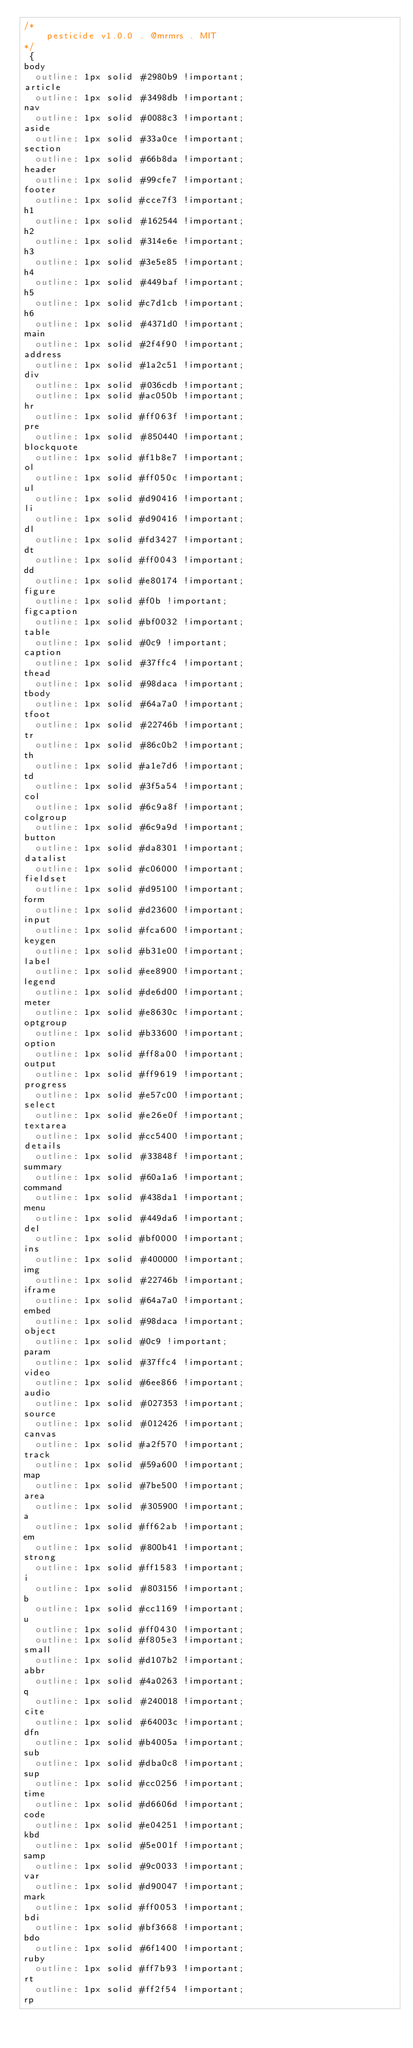Convert code to text. <code><loc_0><loc_0><loc_500><loc_500><_CSS_>/*
    pesticide v1.0.0 . @mrmrs . MIT
*/
 {
body
  outline: 1px solid #2980b9 !important;
article
  outline: 1px solid #3498db !important;
nav
  outline: 1px solid #0088c3 !important;
aside
  outline: 1px solid #33a0ce !important;
section
  outline: 1px solid #66b8da !important;
header
  outline: 1px solid #99cfe7 !important;
footer
  outline: 1px solid #cce7f3 !important;
h1
  outline: 1px solid #162544 !important;
h2
  outline: 1px solid #314e6e !important;
h3
  outline: 1px solid #3e5e85 !important;
h4
  outline: 1px solid #449baf !important;
h5
  outline: 1px solid #c7d1cb !important;
h6
  outline: 1px solid #4371d0 !important;
main
  outline: 1px solid #2f4f90 !important;
address
  outline: 1px solid #1a2c51 !important;
div
  outline: 1px solid #036cdb !important;
  outline: 1px solid #ac050b !important;
hr
  outline: 1px solid #ff063f !important;
pre
  outline: 1px solid #850440 !important;
blockquote
  outline: 1px solid #f1b8e7 !important;
ol
  outline: 1px solid #ff050c !important;
ul
  outline: 1px solid #d90416 !important;
li
  outline: 1px solid #d90416 !important;
dl
  outline: 1px solid #fd3427 !important;
dt
  outline: 1px solid #ff0043 !important;
dd
  outline: 1px solid #e80174 !important;
figure
  outline: 1px solid #f0b !important;
figcaption
  outline: 1px solid #bf0032 !important;
table
  outline: 1px solid #0c9 !important;
caption
  outline: 1px solid #37ffc4 !important;
thead
  outline: 1px solid #98daca !important;
tbody
  outline: 1px solid #64a7a0 !important;
tfoot
  outline: 1px solid #22746b !important;
tr
  outline: 1px solid #86c0b2 !important;
th
  outline: 1px solid #a1e7d6 !important;
td
  outline: 1px solid #3f5a54 !important;
col
  outline: 1px solid #6c9a8f !important;
colgroup
  outline: 1px solid #6c9a9d !important;
button
  outline: 1px solid #da8301 !important;
datalist
  outline: 1px solid #c06000 !important;
fieldset
  outline: 1px solid #d95100 !important;
form
  outline: 1px solid #d23600 !important;
input
  outline: 1px solid #fca600 !important;
keygen
  outline: 1px solid #b31e00 !important;
label
  outline: 1px solid #ee8900 !important;
legend
  outline: 1px solid #de6d00 !important;
meter
  outline: 1px solid #e8630c !important;
optgroup
  outline: 1px solid #b33600 !important;
option
  outline: 1px solid #ff8a00 !important;
output
  outline: 1px solid #ff9619 !important;
progress
  outline: 1px solid #e57c00 !important;
select
  outline: 1px solid #e26e0f !important;
textarea
  outline: 1px solid #cc5400 !important;
details
  outline: 1px solid #33848f !important;
summary
  outline: 1px solid #60a1a6 !important;
command
  outline: 1px solid #438da1 !important;
menu
  outline: 1px solid #449da6 !important;
del
  outline: 1px solid #bf0000 !important;
ins
  outline: 1px solid #400000 !important;
img
  outline: 1px solid #22746b !important;
iframe
  outline: 1px solid #64a7a0 !important;
embed
  outline: 1px solid #98daca !important;
object
  outline: 1px solid #0c9 !important;
param
  outline: 1px solid #37ffc4 !important;
video
  outline: 1px solid #6ee866 !important;
audio
  outline: 1px solid #027353 !important;
source
  outline: 1px solid #012426 !important;
canvas
  outline: 1px solid #a2f570 !important;
track
  outline: 1px solid #59a600 !important;
map
  outline: 1px solid #7be500 !important;
area
  outline: 1px solid #305900 !important;
a
  outline: 1px solid #ff62ab !important;
em
  outline: 1px solid #800b41 !important;
strong
  outline: 1px solid #ff1583 !important;
i
  outline: 1px solid #803156 !important;
b
  outline: 1px solid #cc1169 !important;
u
  outline: 1px solid #ff0430 !important;
  outline: 1px solid #f805e3 !important;
small
  outline: 1px solid #d107b2 !important;
abbr
  outline: 1px solid #4a0263 !important;
q
  outline: 1px solid #240018 !important;
cite
  outline: 1px solid #64003c !important;
dfn
  outline: 1px solid #b4005a !important;
sub
  outline: 1px solid #dba0c8 !important;
sup
  outline: 1px solid #cc0256 !important;
time
  outline: 1px solid #d6606d !important;
code
  outline: 1px solid #e04251 !important;
kbd
  outline: 1px solid #5e001f !important;
samp
  outline: 1px solid #9c0033 !important;
var
  outline: 1px solid #d90047 !important;
mark
  outline: 1px solid #ff0053 !important;
bdi
  outline: 1px solid #bf3668 !important;
bdo
  outline: 1px solid #6f1400 !important;
ruby
  outline: 1px solid #ff7b93 !important;
rt
  outline: 1px solid #ff2f54 !important;
rp</code> 